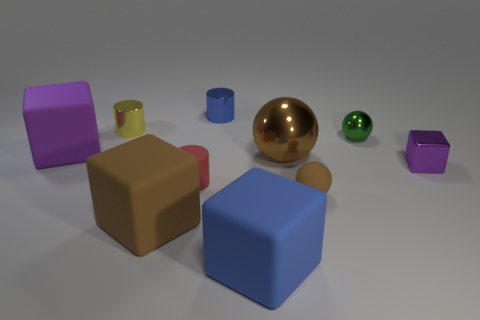The large matte thing that is the same color as the big metal sphere is what shape?
Provide a short and direct response. Cube. What is the color of the metal block?
Offer a very short reply. Purple. There is a purple thing on the left side of the tiny blue shiny cylinder behind the tiny sphere that is to the right of the small brown thing; what shape is it?
Give a very brief answer. Cube. There is a object that is both to the left of the brown matte sphere and on the right side of the blue block; what is it made of?
Offer a terse response. Metal. The purple object left of the purple thing on the right side of the brown matte cube is what shape?
Make the answer very short. Cube. Are there any other things that are the same color as the rubber cylinder?
Ensure brevity in your answer.  No. There is a blue matte thing; does it have the same size as the cube to the left of the tiny yellow object?
Provide a short and direct response. Yes. How many big objects are either red matte cylinders or green shiny objects?
Give a very brief answer. 0. Is the number of yellow metal cubes greater than the number of small purple shiny blocks?
Provide a short and direct response. No. How many tiny things are to the left of the red matte cylinder in front of the purple thing to the right of the large blue cube?
Give a very brief answer. 1. 